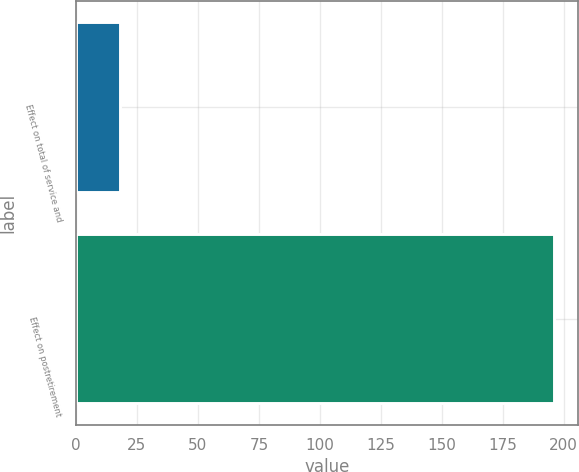Convert chart to OTSL. <chart><loc_0><loc_0><loc_500><loc_500><bar_chart><fcel>Effect on total of service and<fcel>Effect on postretirement<nl><fcel>18<fcel>196<nl></chart> 